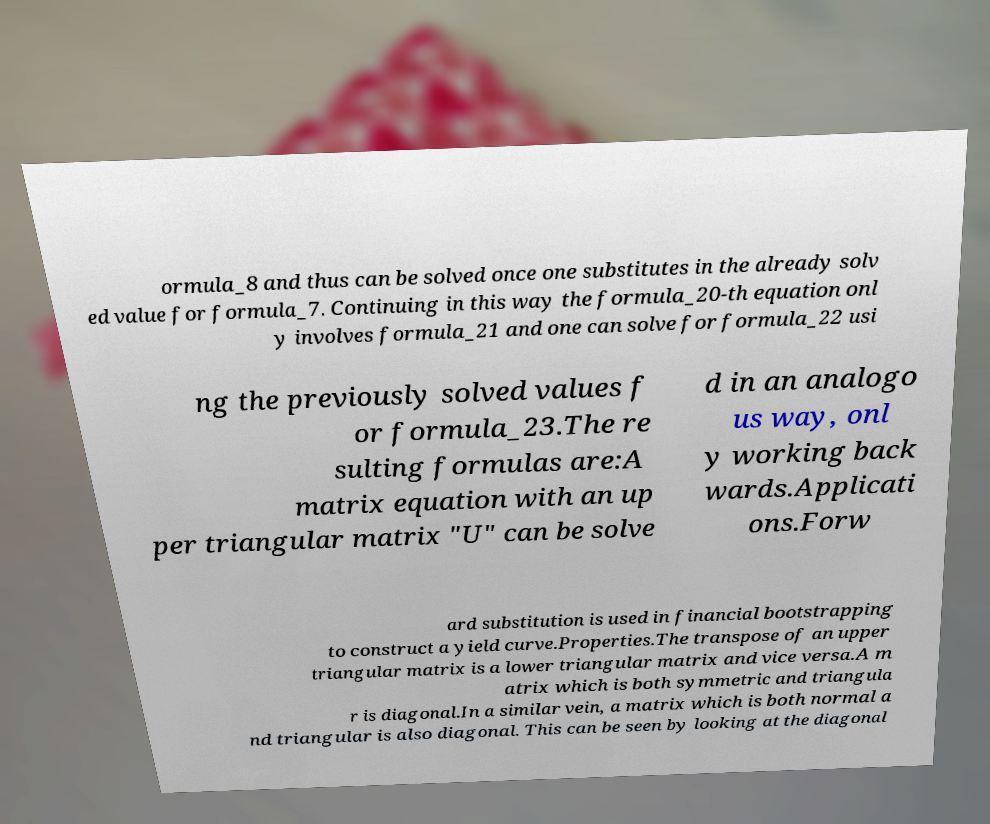For documentation purposes, I need the text within this image transcribed. Could you provide that? ormula_8 and thus can be solved once one substitutes in the already solv ed value for formula_7. Continuing in this way the formula_20-th equation onl y involves formula_21 and one can solve for formula_22 usi ng the previously solved values f or formula_23.The re sulting formulas are:A matrix equation with an up per triangular matrix "U" can be solve d in an analogo us way, onl y working back wards.Applicati ons.Forw ard substitution is used in financial bootstrapping to construct a yield curve.Properties.The transpose of an upper triangular matrix is a lower triangular matrix and vice versa.A m atrix which is both symmetric and triangula r is diagonal.In a similar vein, a matrix which is both normal a nd triangular is also diagonal. This can be seen by looking at the diagonal 